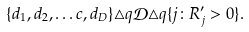<formula> <loc_0><loc_0><loc_500><loc_500>\{ d _ { 1 } , d _ { 2 } , \dots c , d _ { D } \} \triangle q \mathcal { D } \triangle q \{ j \colon R _ { j } ^ { \prime } > 0 \} .</formula> 